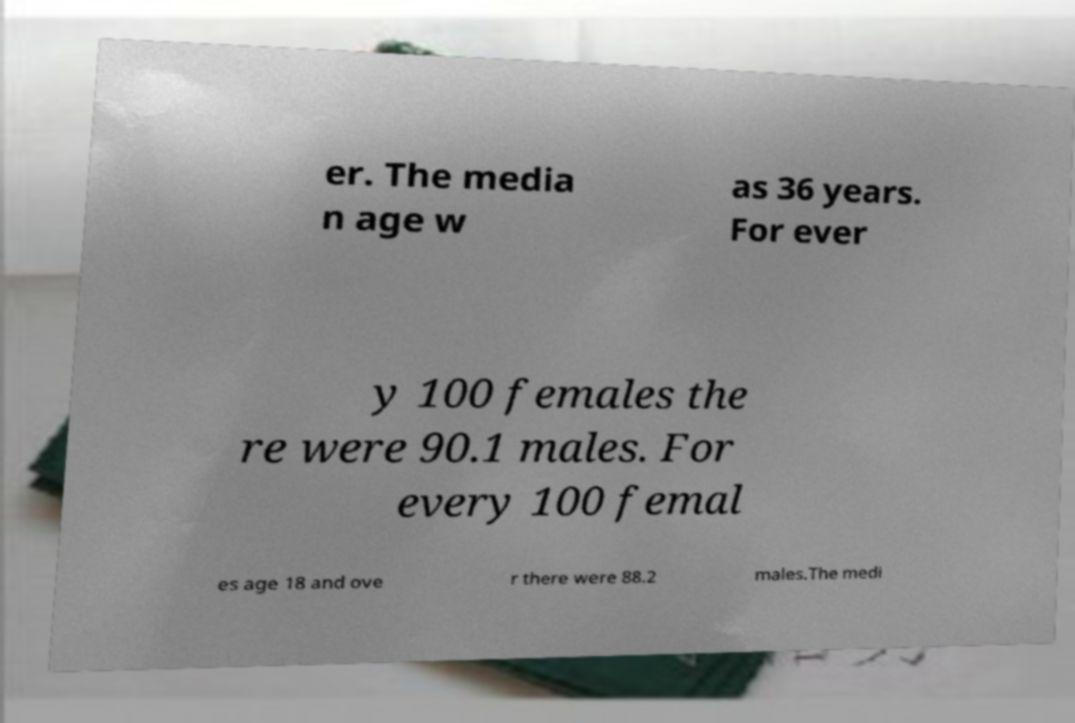Could you assist in decoding the text presented in this image and type it out clearly? er. The media n age w as 36 years. For ever y 100 females the re were 90.1 males. For every 100 femal es age 18 and ove r there were 88.2 males.The medi 